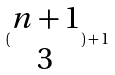<formula> <loc_0><loc_0><loc_500><loc_500>( \begin{matrix} n + 1 \\ 3 \end{matrix} ) + 1</formula> 